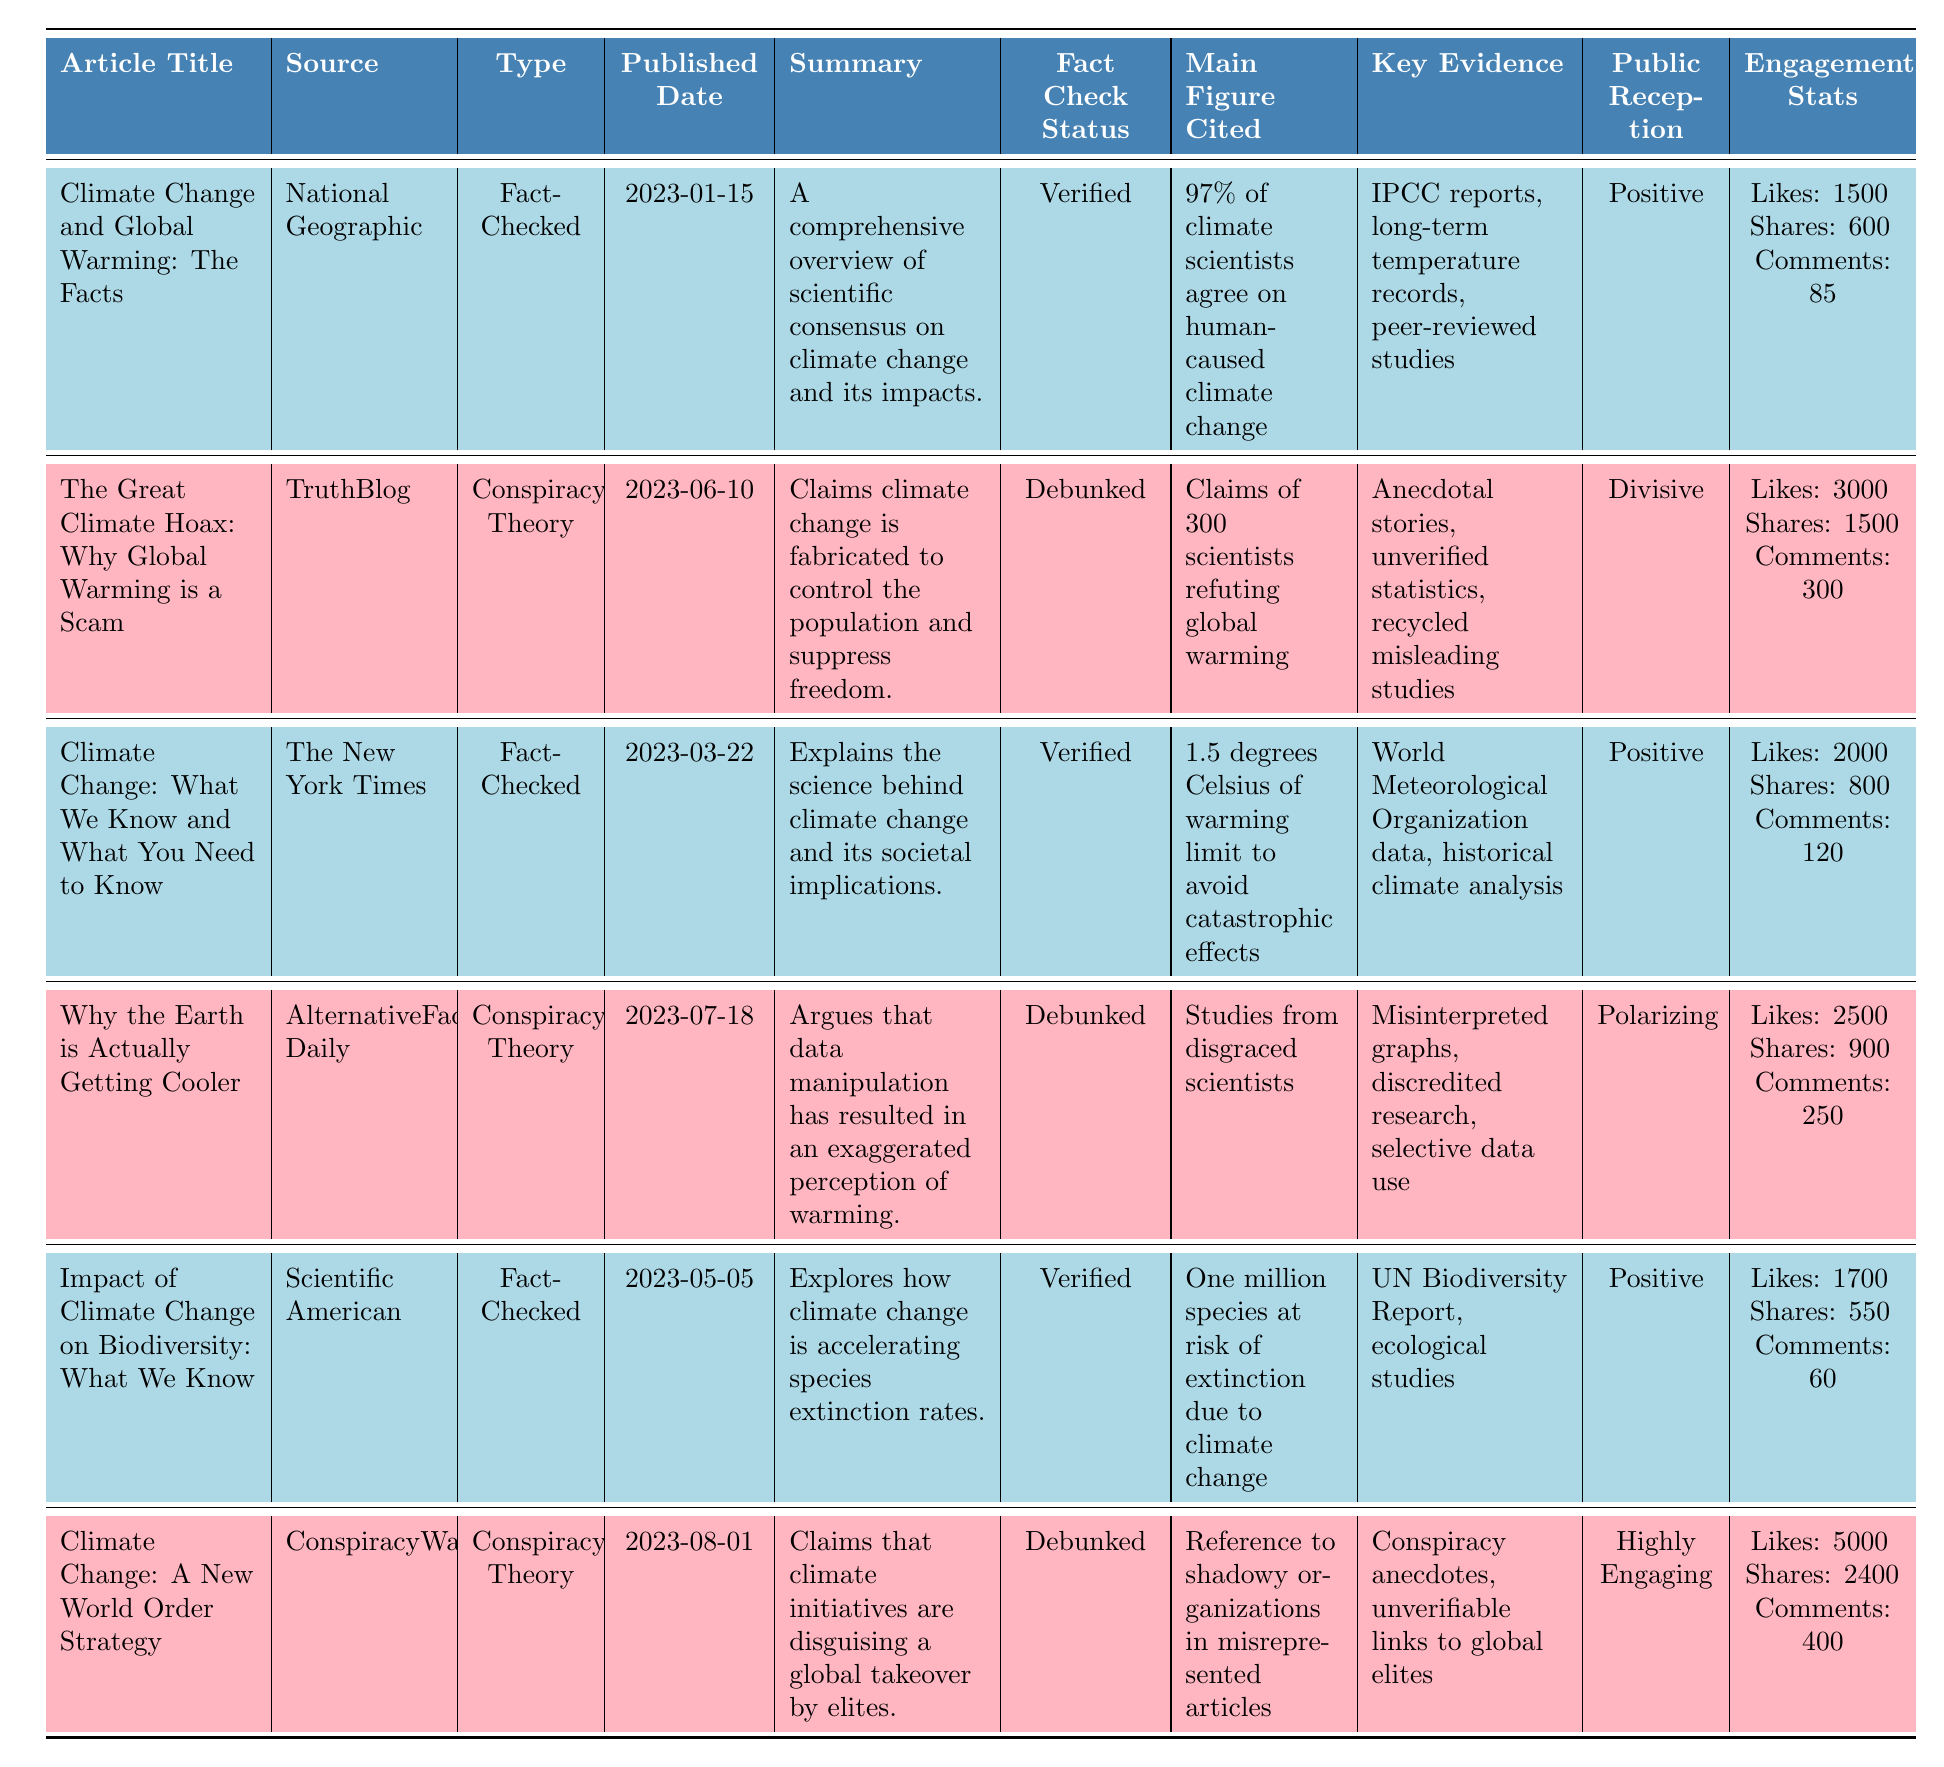What is the publication date of the article "Climate Change and Global Warming: The Facts"? The publication date can be found in the respective row under the "Published Date" column. The article "Climate Change and Global Warming: The Facts" was published on 2023-01-15.
Answer: 2023-01-15 How many likes did "Climate Change: A New World Order Strategy" receive? The number of likes is listed in the engagement statistics for the article in the corresponding row. "Climate Change: A New World Order Strategy" received 5000 likes.
Answer: 5000 Which article has the highest engagement in terms of shares? To determine which article has the highest shares, compare the shares for each article. "Climate Change: A New World Order Strategy" has 2400 shares, which is the highest number compared to the others.
Answer: Climate Change: A New World Order Strategy What percentage of the articles are fact-checked? Out of the 6 articles, 3 are fact-checked. The calculation is (3 fact-checked articles / 6 total articles) * 100 = 50%.
Answer: 50% Is the article "Why the Earth is Actually Getting Cooler" fact-checked? The fact-check status of "Why the Earth is Actually Getting Cooler" is listed as "Debunked," indicating it is not fact-checked.
Answer: No What is the average number of likes for the fact-checked articles? First, identify the articles that are fact-checked: "Climate Change and Global Warming: The Facts" (1500 likes), "Climate Change: What We Know and What You Need to Know" (2000 likes), and "Impact of Climate Change on Biodiversity: What We Know" (1700 likes). Then, sum the likes: 1500 + 2000 + 1700 = 5200. Divide by the number of fact-checked articles (3): 5200 / 3 = approximately 1733.33.
Answer: Approximately 1733.33 What is the public reception of the article "The Great Climate Hoax: Why Global Warming is a Scam"? The public reception is stated directly in the table. For "The Great Climate Hoax: Why Global Warming is a Scam," it is listed as "Divisive."
Answer: Divisive Which article cites a main figure related to species extinction due to climate change? The main figure cited for the article "Impact of Climate Change on Biodiversity: What We Know" is "One million species at risk of extinction due to climate change." You can find this information in the respective row under the column "Main Figure Cited."
Answer: Impact of Climate Change on Biodiversity: What We Know How many comments did "Climate Change and Global Warming: The Facts" receive? The number of comments can be found in the engagement statistics of "Climate Change and Global Warming: The Facts." It received 85 comments.
Answer: 85 What is the correlation between the type of the article and its fact-check status? By examining the table, it appears that all fact-checked articles are labeled "Verified," and all conspiracy theory articles are labeled "Debunked." This indicates a negative correlation, as none of the conspiracy articles are verified, and vice versa.
Answer: Negative correlation Which article received the most comments among conspiracy theory articles? To find this, check the comments for the conspiracy theory articles: "The Great Climate Hoax: Why Global Warming is a Scam" (300 comments), "Why the Earth is Actually Getting Cooler" (250 comments), and "Climate Change: A New World Order Strategy" (400 comments). The article with the most comments is "Climate Change: A New World Order Strategy."
Answer: Climate Change: A New World Order Strategy 